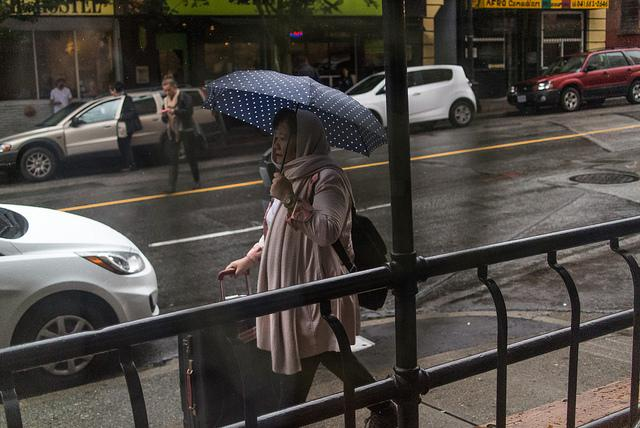Why is the woman carrying luggage? travelling 